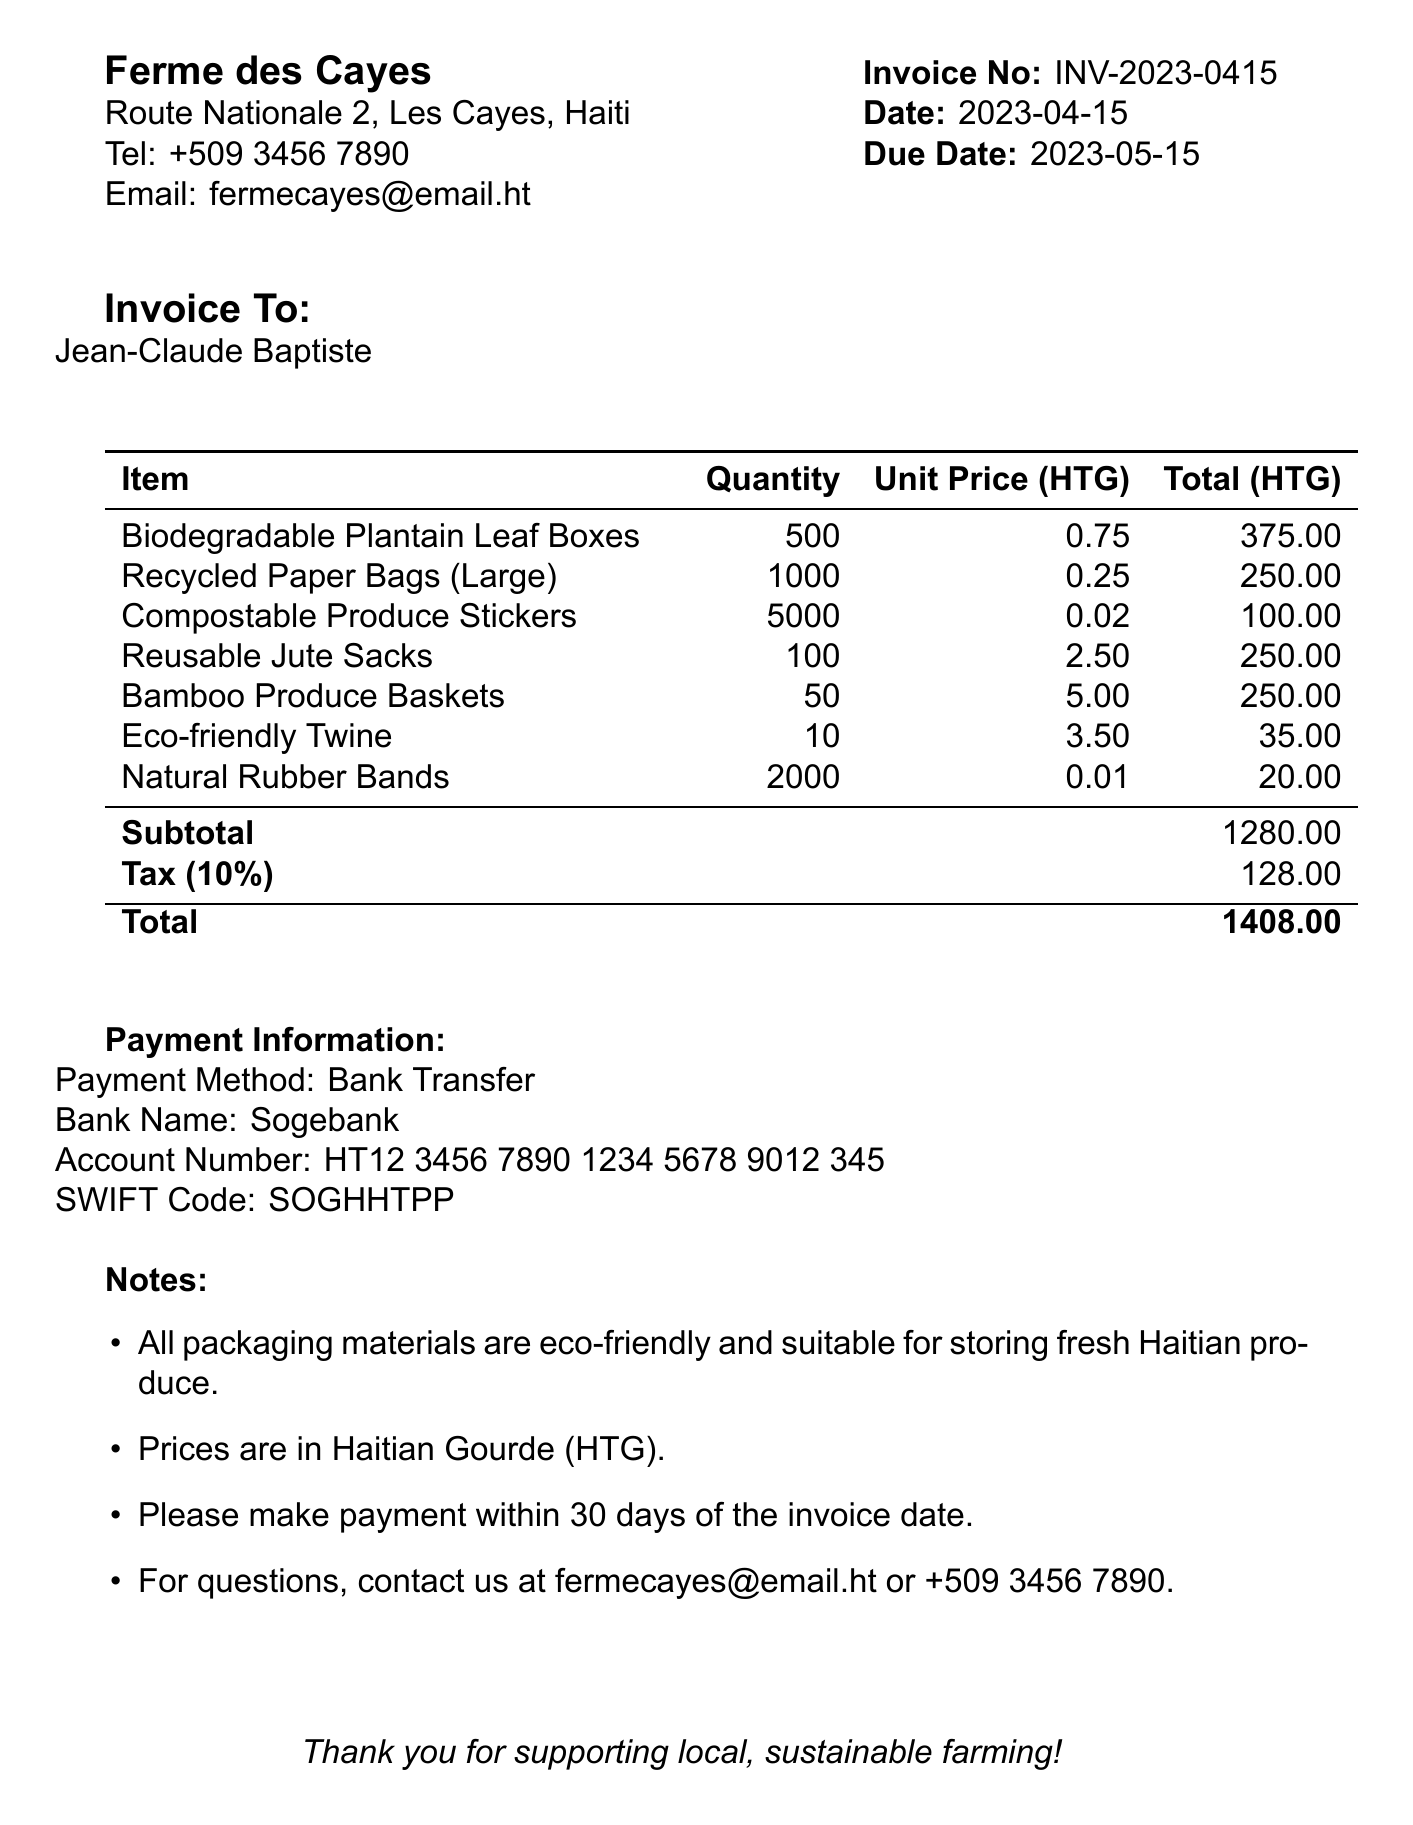What is the invoice number? The invoice number is a unique identifier for the document, which is specified in the invoice details.
Answer: INV-2023-0415 What is the total amount due? The total amount due is found at the bottom of the invoice totals section and includes the subtotal and tax.
Answer: 1408.00 What is the payment due date? The payment due date is explicitly mentioned in the invoice details and indicates when the payment should be made.
Answer: 2023-05-15 How many Recycled Paper Bags (Large) were ordered? The quantity ordered for each item can be found in the packaging materials section, specifically for the Recycled Paper Bags.
Answer: 1000 What is the tax rate applied to the invoice? The tax rate is included in the totals section and indicates the percentage charged for tax on the subtotal.
Answer: 10% How much is the total for Biodegradable Plantain Leaf Boxes? The total for each item is in the packaging materials section, specifically for Biodegradable Plantain Leaf Boxes.
Answer: 375.00 What payment method should be used? The payment method is stated in the payment information section and indicates how the payment should be processed.
Answer: Bank Transfer Which bank is associated with the payment? The bank name is mentioned in the payment information section and indicates where to direct the payment.
Answer: Sogebank What type of packaging materials are specified in the notes? The notes section describes the characteristics of the packaging materials used in the invoice, specifically their suitability for fresh produce.
Answer: Eco-friendly 